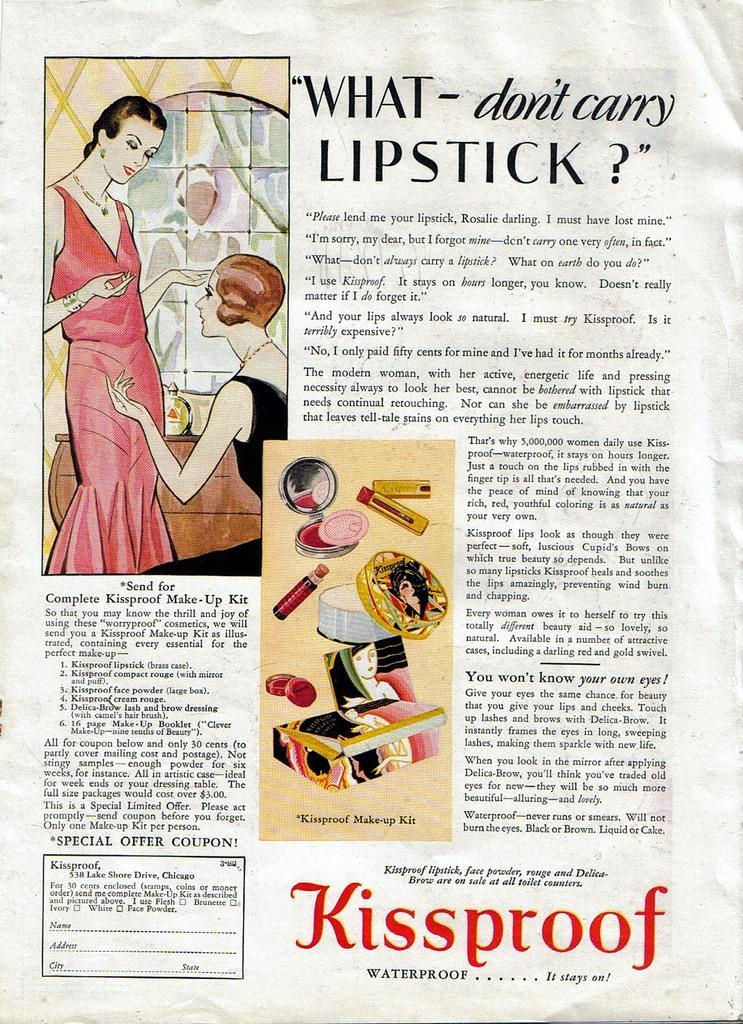Could you give a brief overview of what you see in this image? This might be a poster, in this image there is text and in the center of the image there are some makeup kits like powder, lipstick and mirror. And on the left side of the image there are two women standing, and in the background there is a table and some objects, wall and window. 